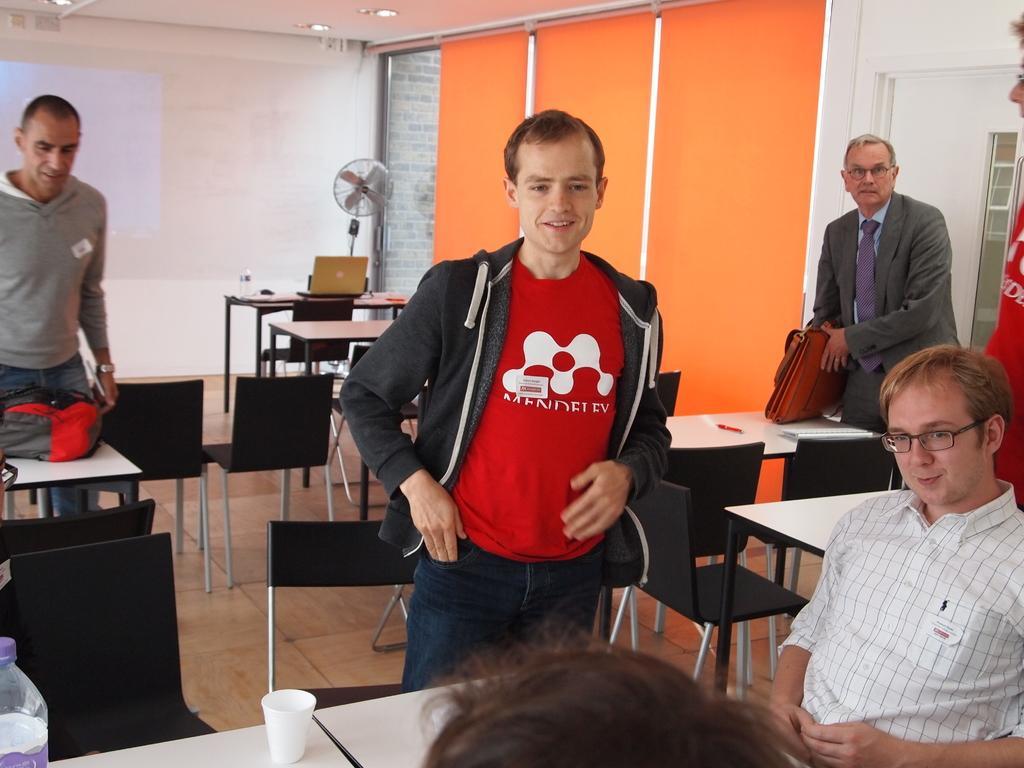Describe this image in one or two sentences. In this picture there are a group of people standing and there is a person sitting on the right side and there are some chairs and behind there is a wall 